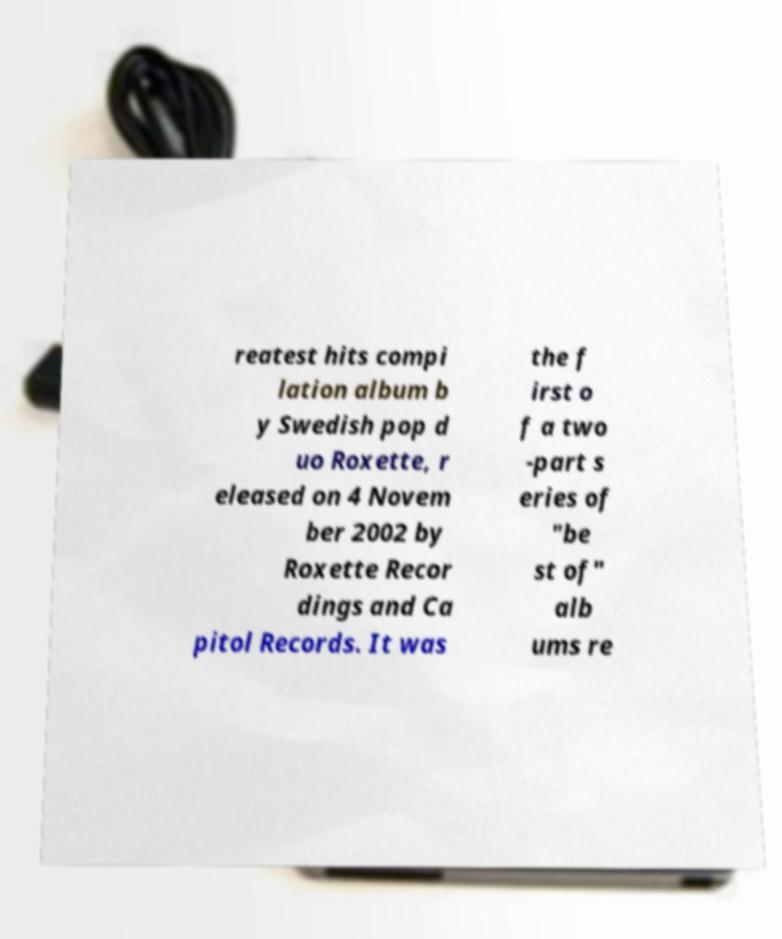There's text embedded in this image that I need extracted. Can you transcribe it verbatim? reatest hits compi lation album b y Swedish pop d uo Roxette, r eleased on 4 Novem ber 2002 by Roxette Recor dings and Ca pitol Records. It was the f irst o f a two -part s eries of "be st of" alb ums re 